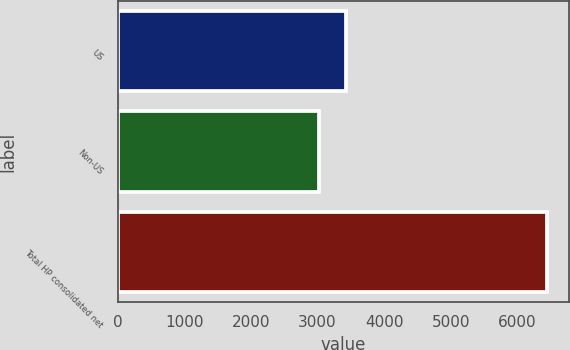Convert chart. <chart><loc_0><loc_0><loc_500><loc_500><bar_chart><fcel>US<fcel>Non-US<fcel>Total HP consolidated net<nl><fcel>3427<fcel>3024<fcel>6451<nl></chart> 